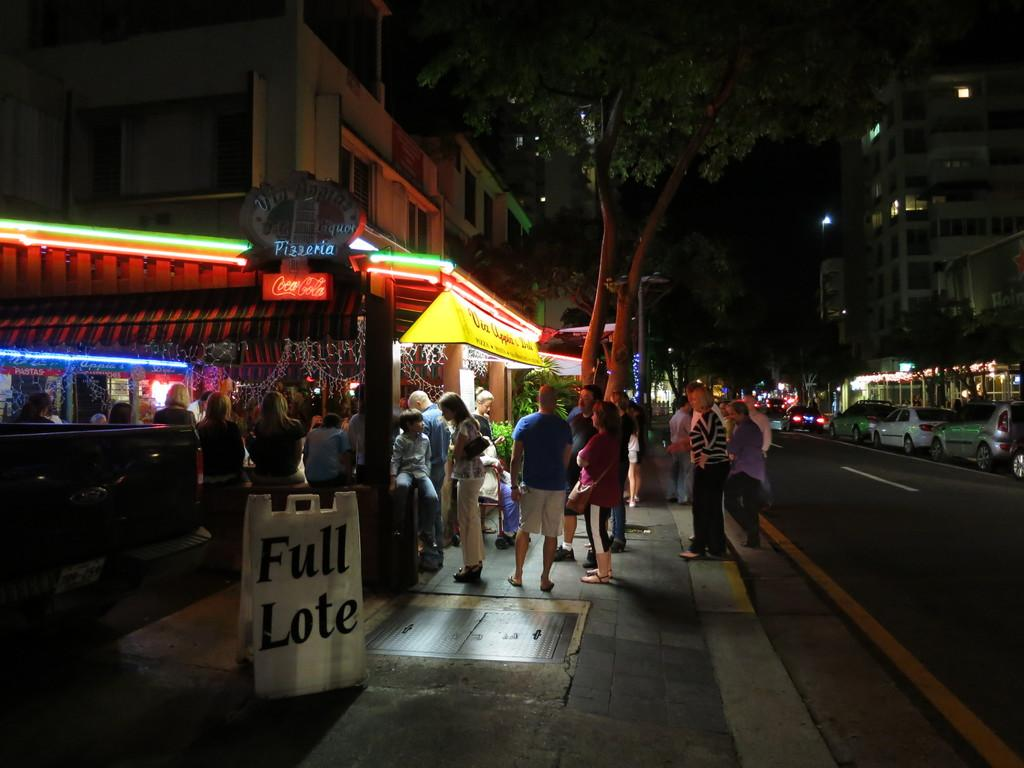How many people are in the image? There are people in the image, but the exact number is not specified. What is the board in the image used for? The purpose of the board in the image is not mentioned in the facts. What can be seen in the background of the image? In the background of the image, there are buildings, trees, and cars on the road. Where is the cave located in the image? There is no cave present in the image. What type of jam is being spread on the board in the image? There is no jam or any food item mentioned in the image. 